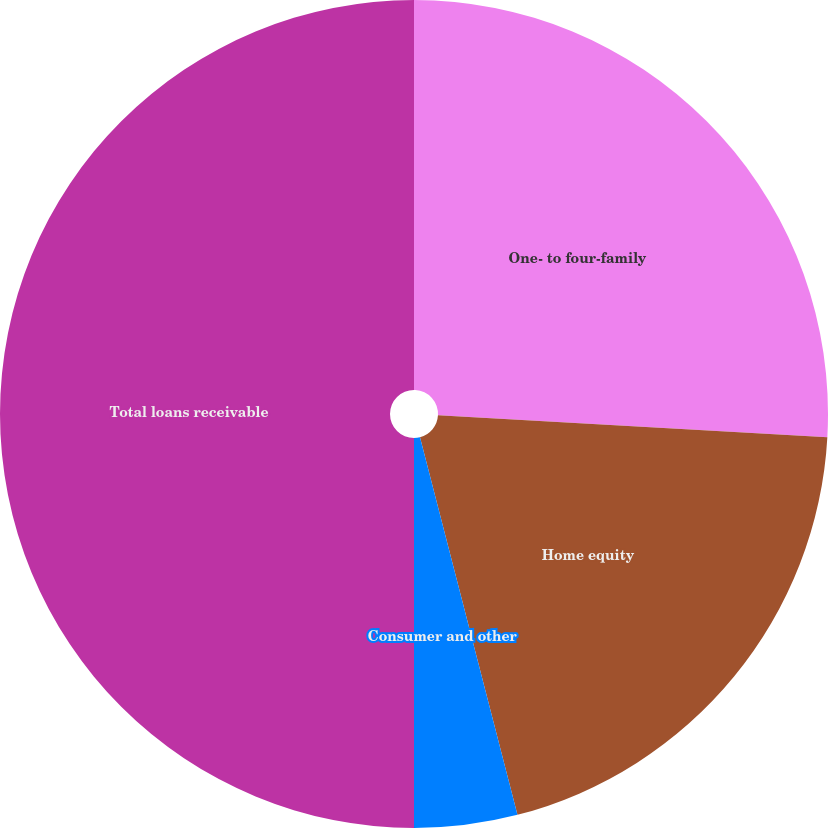Convert chart. <chart><loc_0><loc_0><loc_500><loc_500><pie_chart><fcel>One- to four-family<fcel>Home equity<fcel>Consumer and other<fcel>Total loans receivable<nl><fcel>25.89%<fcel>20.09%<fcel>4.02%<fcel>50.0%<nl></chart> 